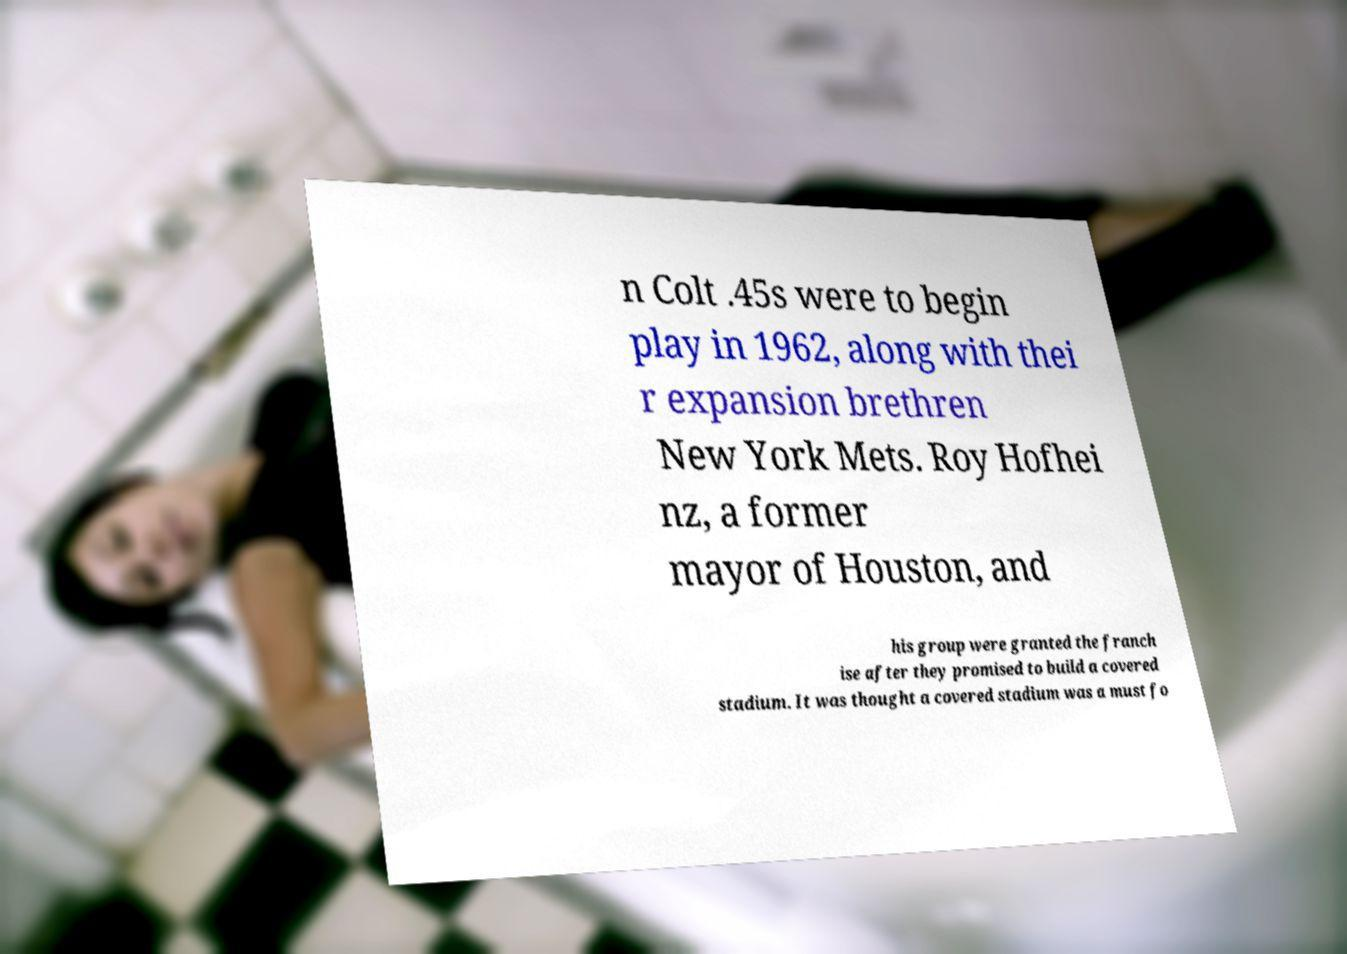Can you read and provide the text displayed in the image?This photo seems to have some interesting text. Can you extract and type it out for me? n Colt .45s were to begin play in 1962, along with thei r expansion brethren New York Mets. Roy Hofhei nz, a former mayor of Houston, and his group were granted the franch ise after they promised to build a covered stadium. It was thought a covered stadium was a must fo 